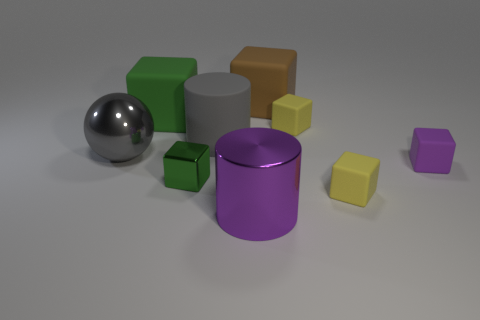Subtract all metallic blocks. How many blocks are left? 5 Subtract all green blocks. How many blocks are left? 4 Add 1 large brown rubber balls. How many objects exist? 10 Subtract 4 cubes. How many cubes are left? 2 Subtract all cylinders. How many objects are left? 7 Subtract all gray cubes. How many blue spheres are left? 0 Subtract 0 brown spheres. How many objects are left? 9 Subtract all cyan blocks. Subtract all cyan cylinders. How many blocks are left? 6 Subtract all tiny cyan metallic things. Subtract all big gray metal spheres. How many objects are left? 8 Add 7 big gray cylinders. How many big gray cylinders are left? 8 